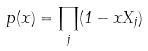<formula> <loc_0><loc_0><loc_500><loc_500>p ( x ) = \prod _ { j } ( 1 - x X _ { j } )</formula> 